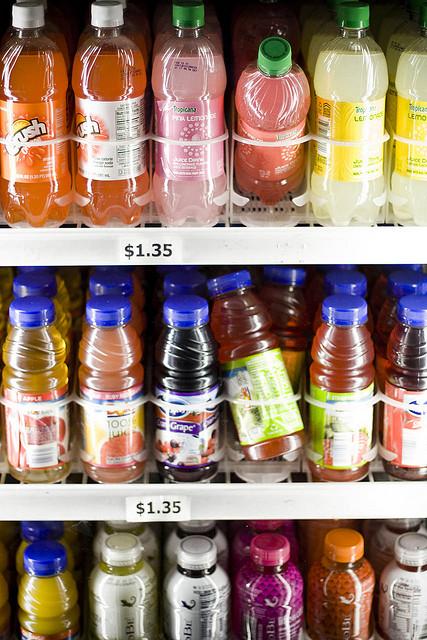Are all of the drinks fruit juices?
Keep it brief. No. Are they all in straight?
Short answer required. No. How much the drinks cost?
Concise answer only. $1.35. 